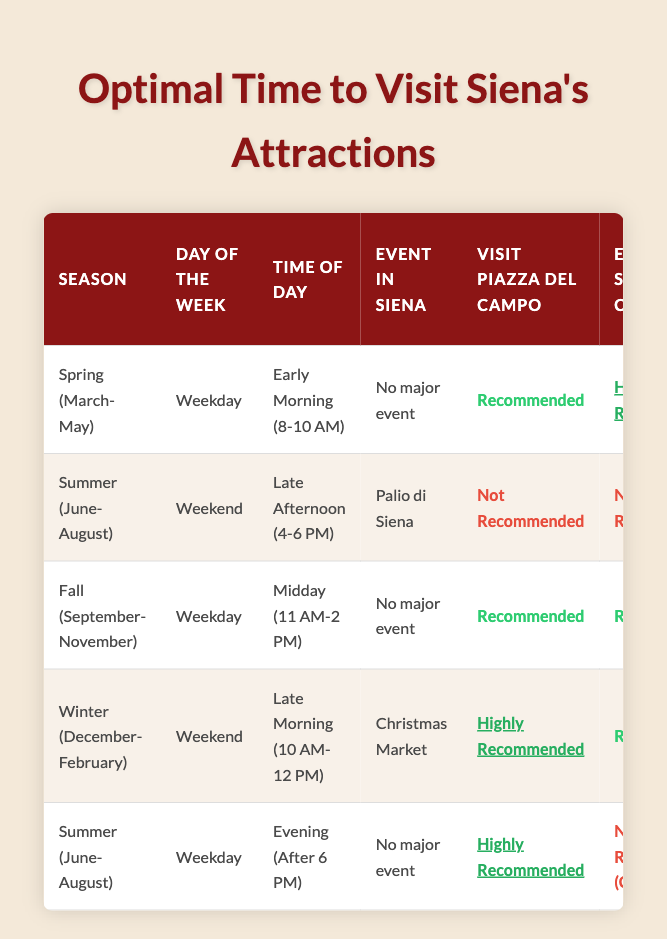What is recommended for visiting Piazza del Campo in Spring on a weekday? According to the table, during Spring (March-May) on a weekday, the recommendation for visiting Piazza del Campo is "Recommended."
Answer: Recommended During which season is it highly recommended to explore Siena Cathedral? The table shows that in both Spring and Fall, exploring Siena Cathedral is "Highly Recommended." Therefore, the seasons for this are Spring (March-May) and Fall (September-November).
Answer: Spring and Fall What time of day should you visit Siena's Historic Center on a Summer weekday? On a Summer (June-August) weekday during the evening (after 6 PM), the table indicates that visiting Siena's Historic Center is "Highly Recommended."
Answer: After 6 PM Is it not recommended to visit the Pinacoteca Nazionale during the Summer late afternoon if the Palio di Siena is happening? Yes, the table states that during the Summer (June-August) late afternoon (4-6 PM) when the Palio di Siena is happening, the visit to the Pinacoteca Nazionale is "Recommended."
Answer: Yes Which attractions are recommended for a Fall weekday visit around midday? For a Fall (September-November) weekday visit at midday (11 AM-2 PM), the table indicates that the recommendations are: Visit Piazza del Campo (Recommended), Explore Siena Cathedral (Recommended), Tour Palazzo Pubblico (Highly Recommended), Visit Pinacoteca Nazionale (Highly Recommended), and Explore Siena's Historic Center (Recommended).
Answer: Multiple attractions recommended 